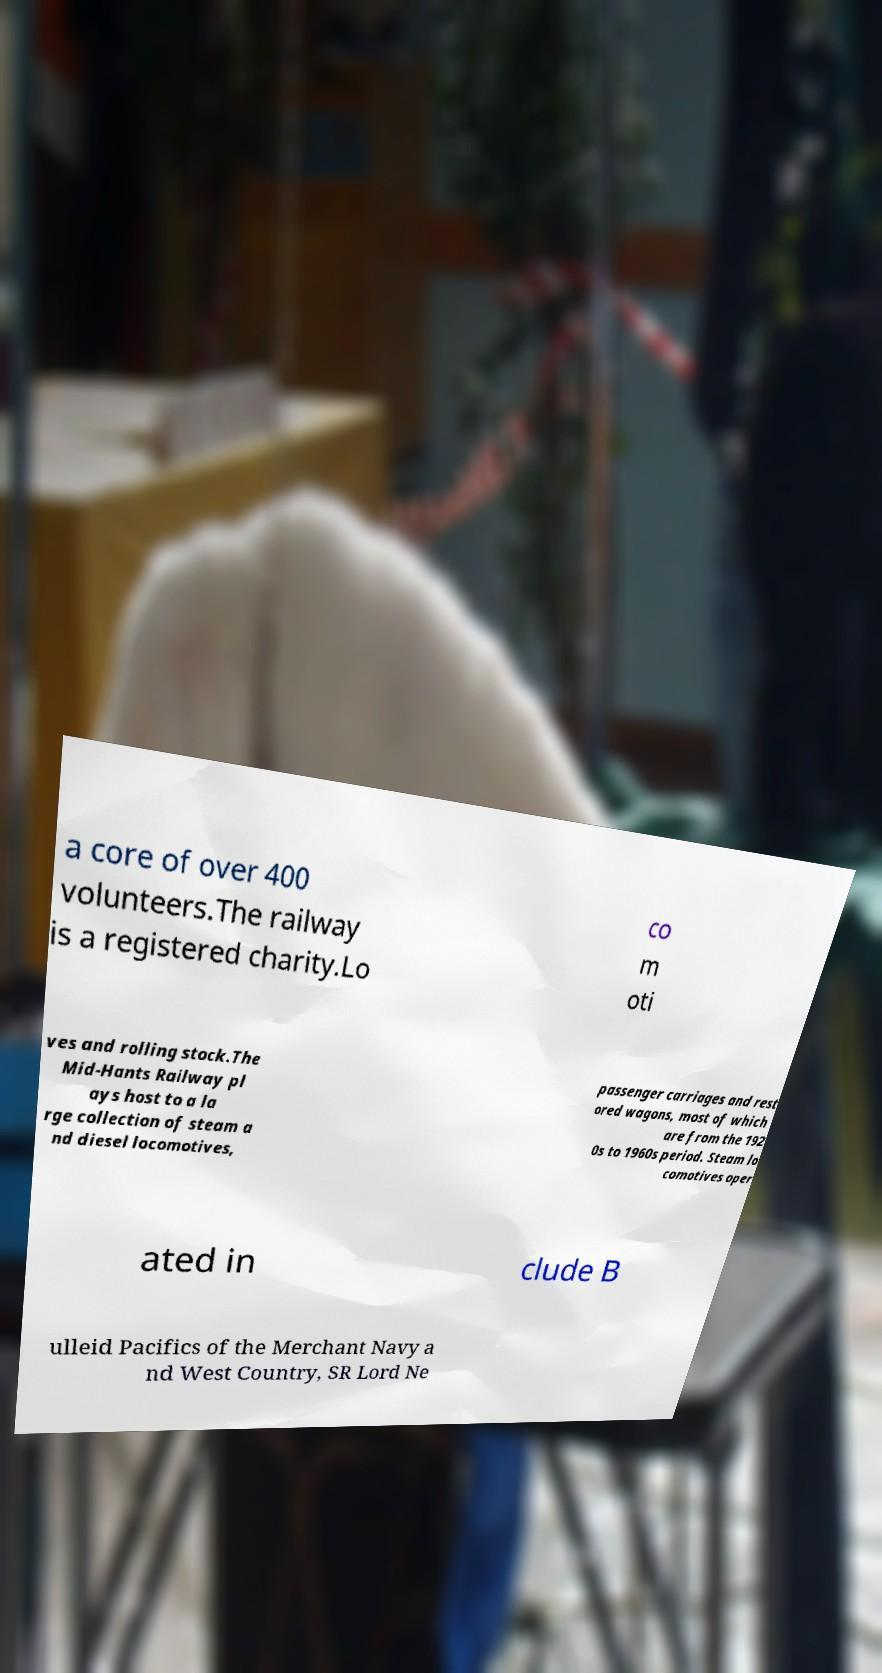Can you accurately transcribe the text from the provided image for me? a core of over 400 volunteers.The railway is a registered charity.Lo co m oti ves and rolling stock.The Mid-Hants Railway pl ays host to a la rge collection of steam a nd diesel locomotives, passenger carriages and rest ored wagons, most of which are from the 192 0s to 1960s period. Steam lo comotives oper ated in clude B ulleid Pacifics of the Merchant Navy a nd West Country, SR Lord Ne 